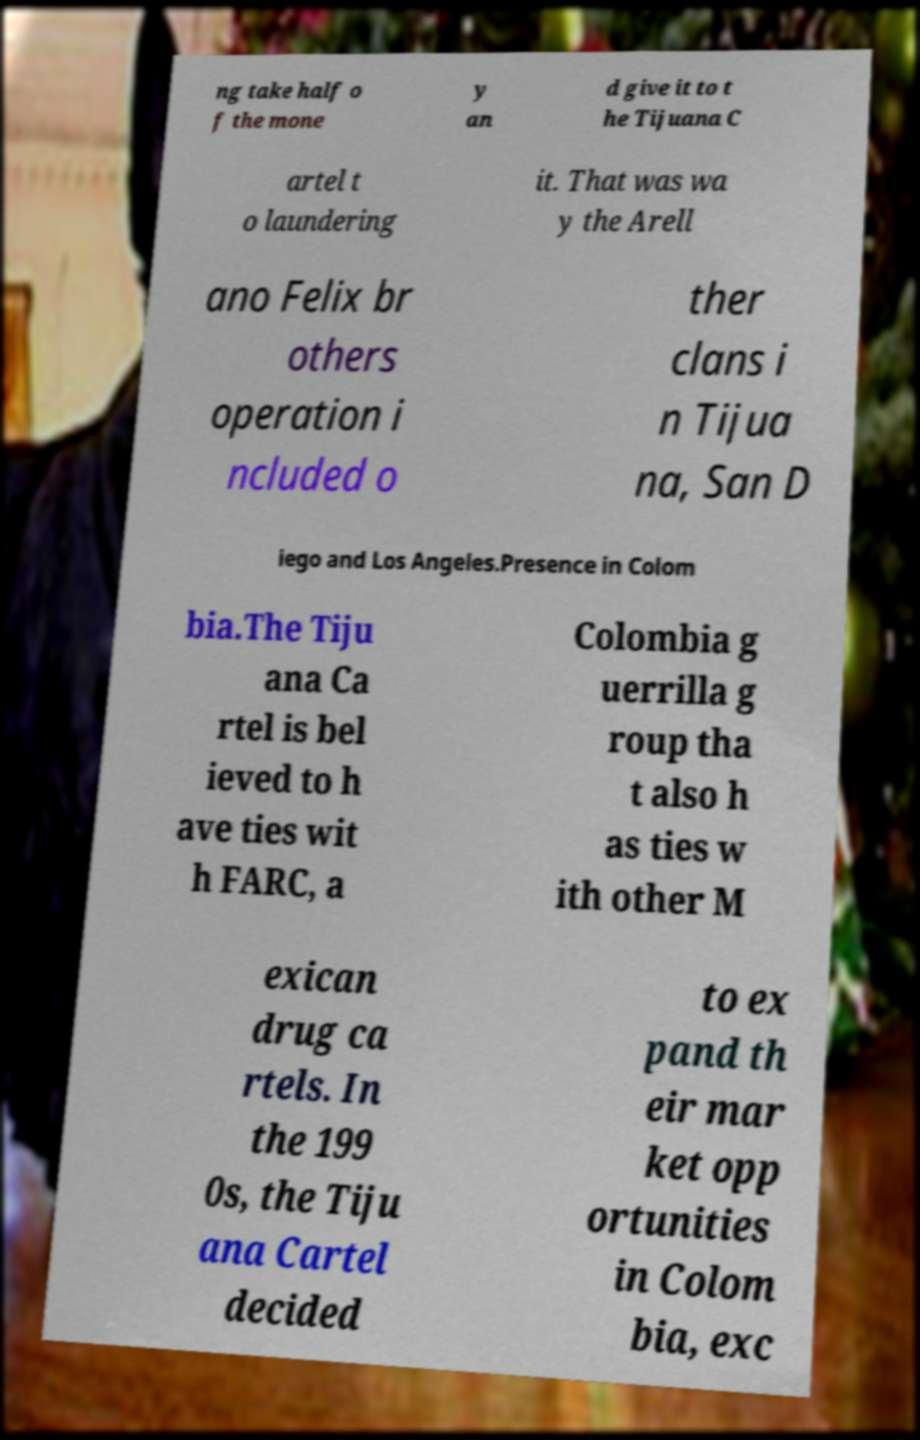For documentation purposes, I need the text within this image transcribed. Could you provide that? ng take half o f the mone y an d give it to t he Tijuana C artel t o laundering it. That was wa y the Arell ano Felix br others operation i ncluded o ther clans i n Tijua na, San D iego and Los Angeles.Presence in Colom bia.The Tiju ana Ca rtel is bel ieved to h ave ties wit h FARC, a Colombia g uerrilla g roup tha t also h as ties w ith other M exican drug ca rtels. In the 199 0s, the Tiju ana Cartel decided to ex pand th eir mar ket opp ortunities in Colom bia, exc 